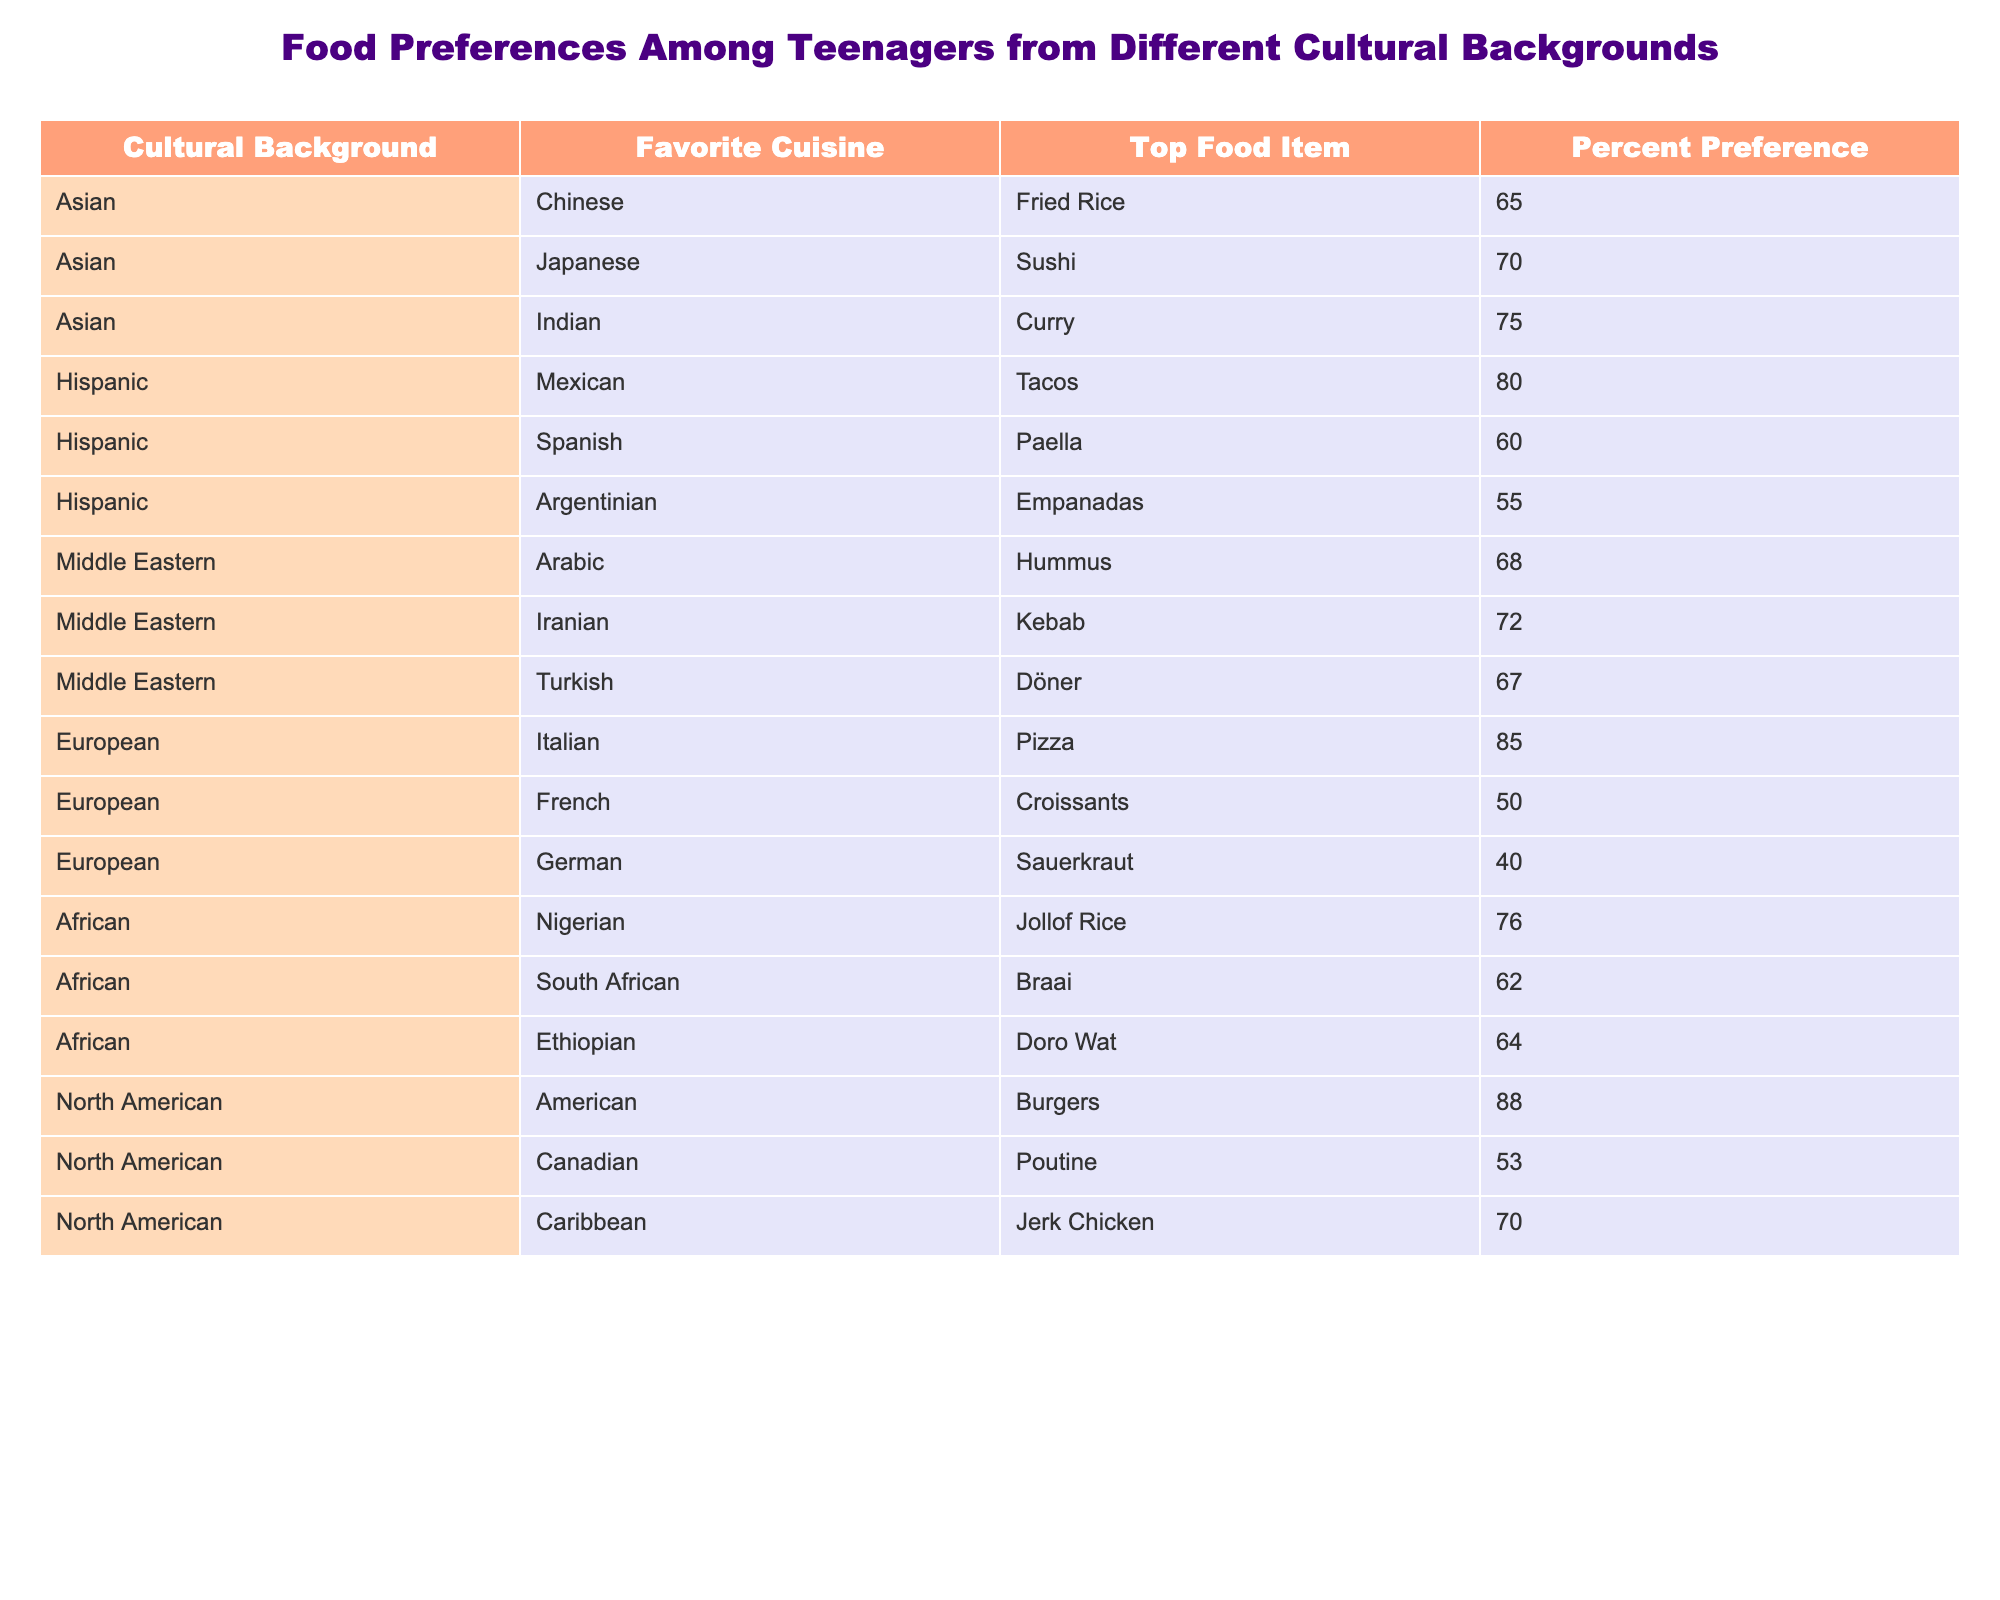What is the favorite food item among North American teenagers? According to the table, the favorite food item among North American teenagers is Burgers, which has the highest percent preference at 88%.
Answer: Burgers Which cultural background has the highest preference for cuisine? When examining the percentages, European cuisine has the highest favorite item, Pizza, at 85%. This is higher than any other cultural background listed.
Answer: European What is the percent preference for Tacos among Hispanic teenagers? The table shows that Tacos have a percent preference of 80% among Hispanic teenagers, making it the top food item within that cultural group.
Answer: 80% How does the percent preference for Sushi compare to that for Hummus? Sushi has a percent preference of 70%, while Hummus has a preference of 68%. Comparing these two values, Sushi is preferred slightly more than Hummus.
Answer: Sushi is preferred more than Hummus What is the average percent preference for food items among Asian teenagers? The percent preferences for Asian favorites are: Fried Rice (65%), Sushi (70%), and Curry (75%). To find the average, we add these up: 65 + 70 + 75 = 210. Dividing by the number of items (3), we get 210 / 3 = 70.
Answer: 70 Does any food item from the Middle Eastern group have a preference of over 70%? Yes, the food item Kebab has a percent preference of 72%, which is over 70%.
Answer: Yes Which cultural background has the least preferred food item and what is it? The least preferred food item in the table is Sauerkraut from the German cultural background, with a percent preference of 40%.
Answer: German/Sauerkraut What is the total percent preference for food items among African teenagers? The preferences for African food items are Jollof Rice (76%), Braai (62%), and Doro Wat (64%). Adding these together gives us: 76 + 62 + 64 = 202. Thus, the total percent preference is 202.
Answer: 202 